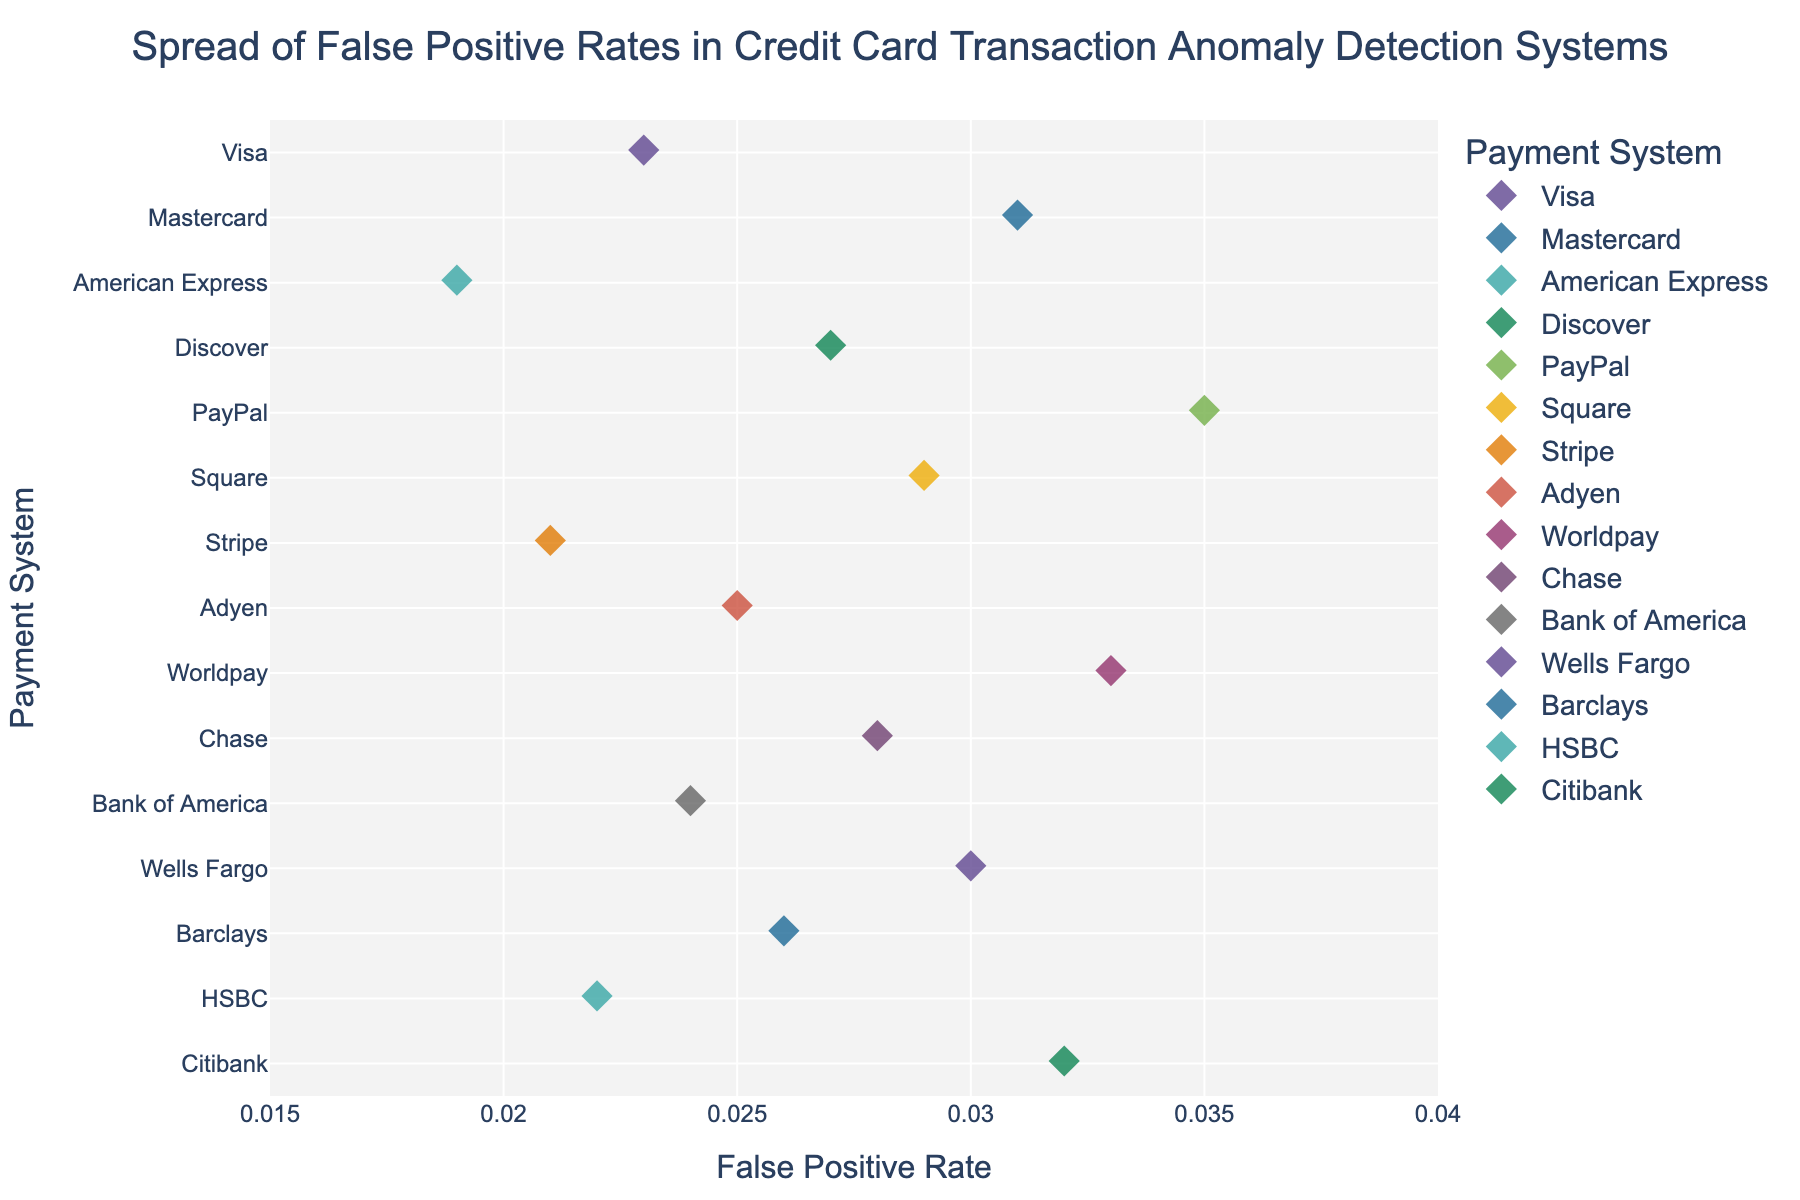How many payment systems are compared in the figure? Count the number of distinct payment system labels on the y-axis.
Answer: 15 What is the range of false positive rates shown on the x-axis? Look at the x-axis range values at both ends.
Answer: 0.015 to 0.04 Which payment system has the highest false positive rate, and what is it? Identify the data point farthest to the right on the strip plot. The label on the y-axis gives the payment system, and its position on the x-axis gives the false positive rate.
Answer: PayPal (0.035) What is the average false positive rate across all systems? Sum all the false positive rates and divide by the number of systems: (0.023 + 0.031 + 0.019 + 0.027 + 0.035 + 0.029 + 0.021 + 0.025 + 0.033 + 0.028 + 0.024 + 0.030 + 0.026 + 0.022 + 0.032) / 15 = 0.027.
Answer: 0.027 Which payment system has the lowest false positive rate? Identify the data point farthest to the left on the strip plot. The label on the y-axis gives the payment system.
Answer: American Express How do the false positive rates of Visa and Mastercard compare? Locate the data points for Visa and Mastercard. Check the x-axis positions of these points.
Answer: Visa is lower than Mastercard Are there any payment systems with the same false positive rate? By observing the x-axis placements, look for overlap or identical positions of points.
Answer: No What is the difference between the false positive rates of Stripe and Citibank? Subtract the false positive rate of Stripe (0.021) from that of Citibank (0.032): 0.032 - 0.021 = 0.011.
Answer: 0.011 Which system has a false positive rate nearest to 0.03? Identify the data point closest to 0.03 on the x-axis and find the corresponding y-axis label.
Answer: Mastercard What is the median false positive rate of the systems? Organize the false positive rates in ascending order and find the middle value. The rates are: 0.019, 0.021, 0.022, 0.023, 0.024, 0.025, 0.026, 0.027, 0.028, 0.029, 0.030, 0.031, 0.032, 0.033, 0.035. The median is the 8th value: 0.027.
Answer: 0.027 